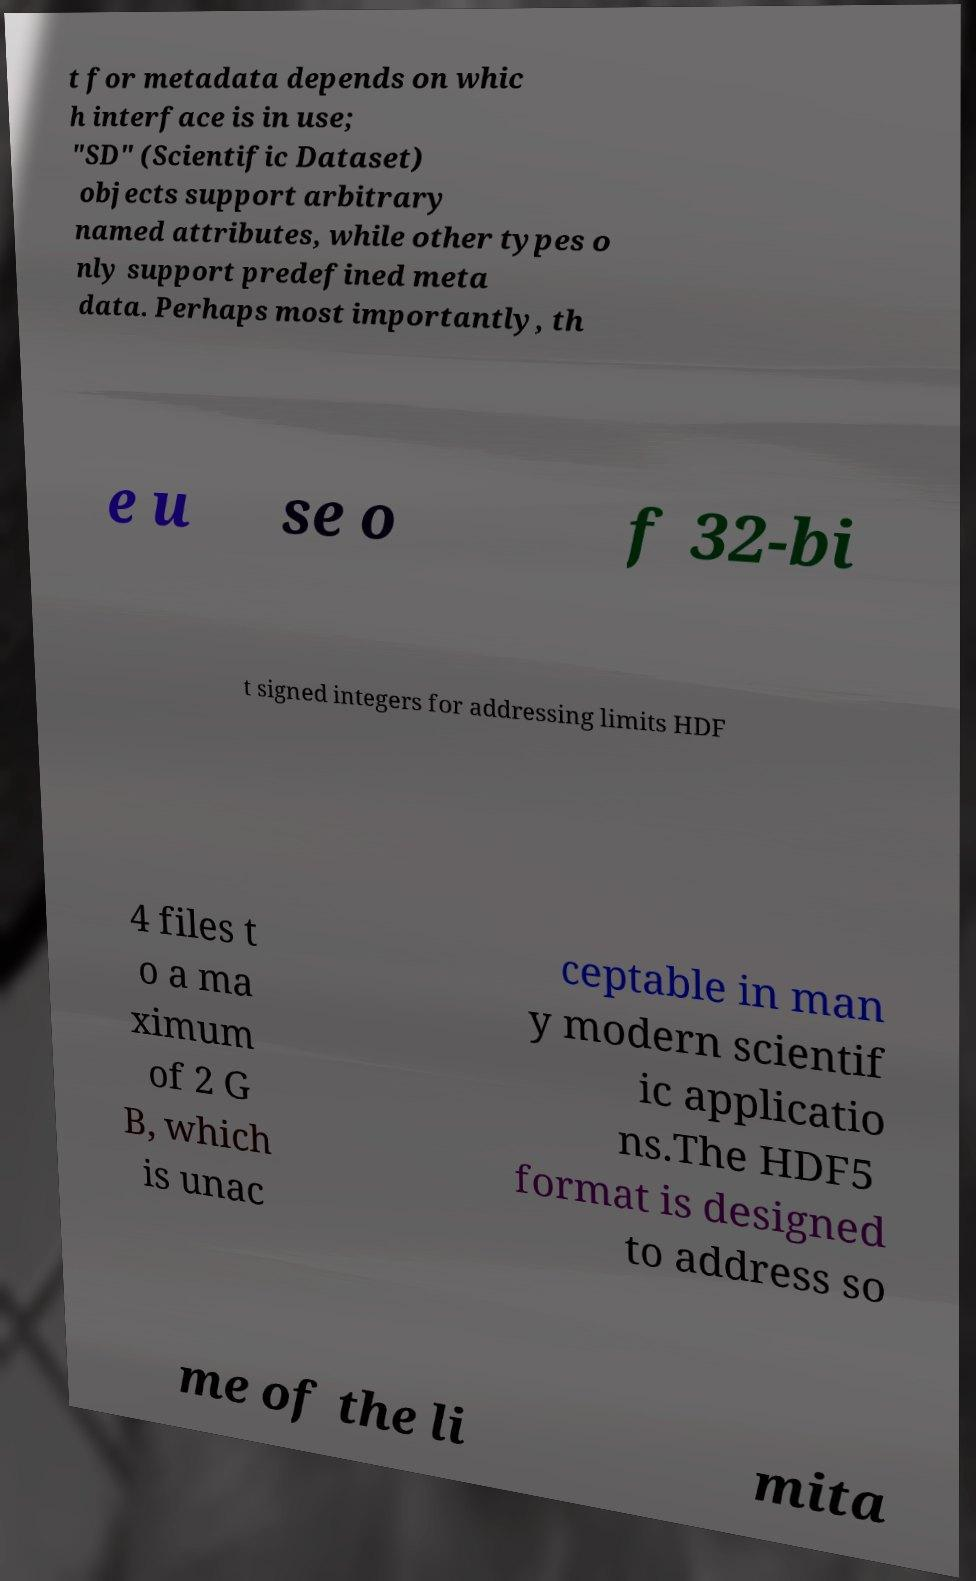Could you extract and type out the text from this image? t for metadata depends on whic h interface is in use; "SD" (Scientific Dataset) objects support arbitrary named attributes, while other types o nly support predefined meta data. Perhaps most importantly, th e u se o f 32-bi t signed integers for addressing limits HDF 4 files t o a ma ximum of 2 G B, which is unac ceptable in man y modern scientif ic applicatio ns.The HDF5 format is designed to address so me of the li mita 